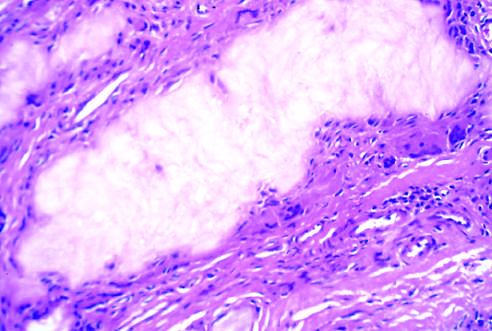s an aggregate of dissolved urate crystals surrounded by reactive fibroblasts, mononuclear inflammatory cells, and giant cells?
Answer the question using a single word or phrase. Yes 